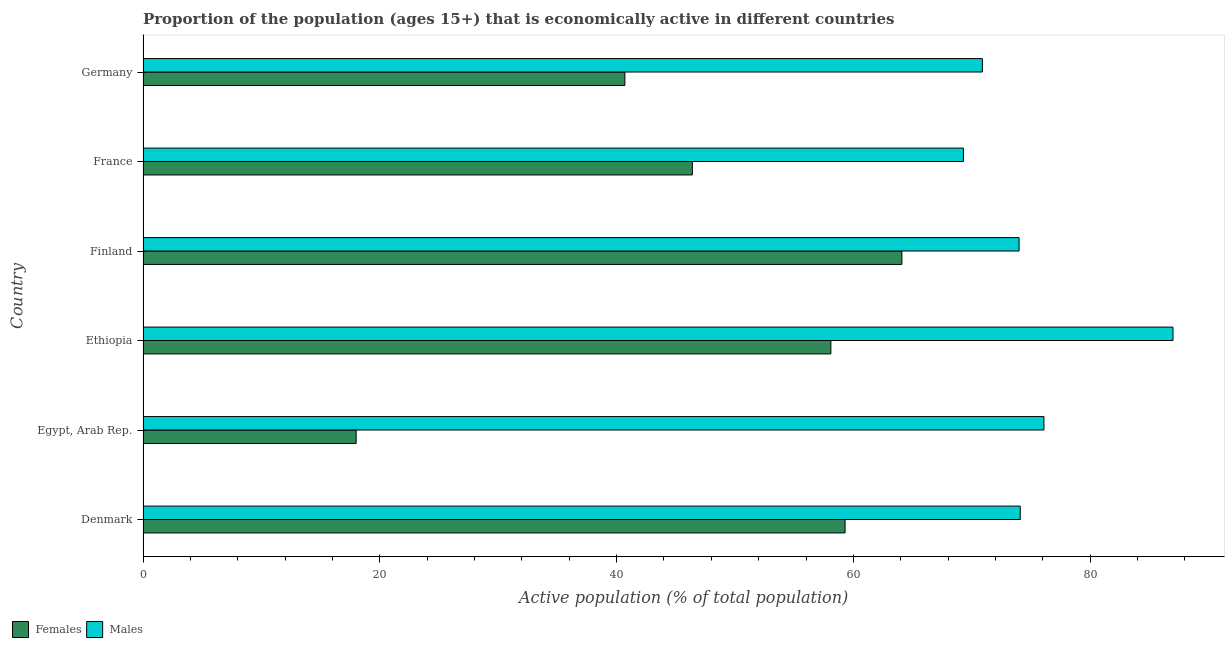How many different coloured bars are there?
Give a very brief answer. 2. Are the number of bars on each tick of the Y-axis equal?
Offer a terse response. Yes. How many bars are there on the 1st tick from the bottom?
Make the answer very short. 2. What is the label of the 2nd group of bars from the top?
Your response must be concise. France. In how many cases, is the number of bars for a given country not equal to the number of legend labels?
Your answer should be very brief. 0. What is the percentage of economically active male population in Germany?
Offer a very short reply. 70.9. Across all countries, what is the maximum percentage of economically active female population?
Keep it short and to the point. 64.1. Across all countries, what is the minimum percentage of economically active male population?
Your answer should be very brief. 69.3. In which country was the percentage of economically active female population maximum?
Provide a short and direct response. Finland. In which country was the percentage of economically active female population minimum?
Provide a succinct answer. Egypt, Arab Rep. What is the total percentage of economically active female population in the graph?
Your response must be concise. 286.6. What is the difference between the percentage of economically active male population in Finland and that in France?
Your answer should be compact. 4.7. What is the difference between the percentage of economically active male population in Finland and the percentage of economically active female population in France?
Ensure brevity in your answer.  27.6. What is the average percentage of economically active female population per country?
Your response must be concise. 47.77. What is the difference between the percentage of economically active male population and percentage of economically active female population in Denmark?
Your response must be concise. 14.8. What is the ratio of the percentage of economically active male population in Egypt, Arab Rep. to that in Germany?
Offer a terse response. 1.07. Is the percentage of economically active male population in Egypt, Arab Rep. less than that in Finland?
Provide a short and direct response. No. What is the difference between the highest and the lowest percentage of economically active female population?
Your response must be concise. 46.1. In how many countries, is the percentage of economically active male population greater than the average percentage of economically active male population taken over all countries?
Provide a succinct answer. 2. Is the sum of the percentage of economically active female population in Ethiopia and Finland greater than the maximum percentage of economically active male population across all countries?
Your answer should be compact. Yes. What does the 1st bar from the top in Ethiopia represents?
Provide a succinct answer. Males. What does the 2nd bar from the bottom in France represents?
Your answer should be compact. Males. What is the title of the graph?
Provide a short and direct response. Proportion of the population (ages 15+) that is economically active in different countries. Does "Infant" appear as one of the legend labels in the graph?
Provide a short and direct response. No. What is the label or title of the X-axis?
Provide a succinct answer. Active population (% of total population). What is the label or title of the Y-axis?
Provide a succinct answer. Country. What is the Active population (% of total population) in Females in Denmark?
Offer a terse response. 59.3. What is the Active population (% of total population) in Males in Denmark?
Ensure brevity in your answer.  74.1. What is the Active population (% of total population) of Males in Egypt, Arab Rep.?
Give a very brief answer. 76.1. What is the Active population (% of total population) in Females in Ethiopia?
Provide a succinct answer. 58.1. What is the Active population (% of total population) in Females in Finland?
Make the answer very short. 64.1. What is the Active population (% of total population) in Males in Finland?
Provide a short and direct response. 74. What is the Active population (% of total population) in Females in France?
Your answer should be compact. 46.4. What is the Active population (% of total population) of Males in France?
Ensure brevity in your answer.  69.3. What is the Active population (% of total population) in Females in Germany?
Make the answer very short. 40.7. What is the Active population (% of total population) of Males in Germany?
Your response must be concise. 70.9. Across all countries, what is the maximum Active population (% of total population) in Females?
Offer a terse response. 64.1. Across all countries, what is the minimum Active population (% of total population) in Females?
Offer a terse response. 18. Across all countries, what is the minimum Active population (% of total population) in Males?
Your response must be concise. 69.3. What is the total Active population (% of total population) of Females in the graph?
Your answer should be compact. 286.6. What is the total Active population (% of total population) of Males in the graph?
Your response must be concise. 451.4. What is the difference between the Active population (% of total population) of Females in Denmark and that in Egypt, Arab Rep.?
Offer a terse response. 41.3. What is the difference between the Active population (% of total population) of Males in Denmark and that in Egypt, Arab Rep.?
Give a very brief answer. -2. What is the difference between the Active population (% of total population) of Females in Denmark and that in Ethiopia?
Your answer should be compact. 1.2. What is the difference between the Active population (% of total population) of Males in Denmark and that in Ethiopia?
Ensure brevity in your answer.  -12.9. What is the difference between the Active population (% of total population) in Males in Denmark and that in Finland?
Provide a succinct answer. 0.1. What is the difference between the Active population (% of total population) in Females in Denmark and that in Germany?
Provide a short and direct response. 18.6. What is the difference between the Active population (% of total population) in Males in Denmark and that in Germany?
Ensure brevity in your answer.  3.2. What is the difference between the Active population (% of total population) in Females in Egypt, Arab Rep. and that in Ethiopia?
Your answer should be very brief. -40.1. What is the difference between the Active population (% of total population) in Females in Egypt, Arab Rep. and that in Finland?
Your answer should be very brief. -46.1. What is the difference between the Active population (% of total population) of Females in Egypt, Arab Rep. and that in France?
Offer a very short reply. -28.4. What is the difference between the Active population (% of total population) of Females in Egypt, Arab Rep. and that in Germany?
Provide a short and direct response. -22.7. What is the difference between the Active population (% of total population) of Males in Ethiopia and that in Finland?
Your answer should be compact. 13. What is the difference between the Active population (% of total population) of Males in Ethiopia and that in France?
Provide a short and direct response. 17.7. What is the difference between the Active population (% of total population) in Males in Ethiopia and that in Germany?
Ensure brevity in your answer.  16.1. What is the difference between the Active population (% of total population) in Males in Finland and that in France?
Provide a succinct answer. 4.7. What is the difference between the Active population (% of total population) of Females in Finland and that in Germany?
Offer a terse response. 23.4. What is the difference between the Active population (% of total population) of Females in France and that in Germany?
Offer a very short reply. 5.7. What is the difference between the Active population (% of total population) in Males in France and that in Germany?
Provide a short and direct response. -1.6. What is the difference between the Active population (% of total population) in Females in Denmark and the Active population (% of total population) in Males in Egypt, Arab Rep.?
Keep it short and to the point. -16.8. What is the difference between the Active population (% of total population) of Females in Denmark and the Active population (% of total population) of Males in Ethiopia?
Your answer should be very brief. -27.7. What is the difference between the Active population (% of total population) in Females in Denmark and the Active population (% of total population) in Males in Finland?
Ensure brevity in your answer.  -14.7. What is the difference between the Active population (% of total population) in Females in Denmark and the Active population (% of total population) in Males in France?
Your response must be concise. -10. What is the difference between the Active population (% of total population) of Females in Denmark and the Active population (% of total population) of Males in Germany?
Your answer should be compact. -11.6. What is the difference between the Active population (% of total population) in Females in Egypt, Arab Rep. and the Active population (% of total population) in Males in Ethiopia?
Keep it short and to the point. -69. What is the difference between the Active population (% of total population) in Females in Egypt, Arab Rep. and the Active population (% of total population) in Males in Finland?
Provide a succinct answer. -56. What is the difference between the Active population (% of total population) in Females in Egypt, Arab Rep. and the Active population (% of total population) in Males in France?
Offer a very short reply. -51.3. What is the difference between the Active population (% of total population) of Females in Egypt, Arab Rep. and the Active population (% of total population) of Males in Germany?
Give a very brief answer. -52.9. What is the difference between the Active population (% of total population) in Females in Ethiopia and the Active population (% of total population) in Males in Finland?
Your answer should be compact. -15.9. What is the difference between the Active population (% of total population) of Females in Ethiopia and the Active population (% of total population) of Males in France?
Keep it short and to the point. -11.2. What is the difference between the Active population (% of total population) in Females in Finland and the Active population (% of total population) in Males in France?
Provide a succinct answer. -5.2. What is the difference between the Active population (% of total population) of Females in Finland and the Active population (% of total population) of Males in Germany?
Ensure brevity in your answer.  -6.8. What is the difference between the Active population (% of total population) in Females in France and the Active population (% of total population) in Males in Germany?
Make the answer very short. -24.5. What is the average Active population (% of total population) in Females per country?
Keep it short and to the point. 47.77. What is the average Active population (% of total population) in Males per country?
Offer a very short reply. 75.23. What is the difference between the Active population (% of total population) in Females and Active population (% of total population) in Males in Denmark?
Provide a succinct answer. -14.8. What is the difference between the Active population (% of total population) of Females and Active population (% of total population) of Males in Egypt, Arab Rep.?
Keep it short and to the point. -58.1. What is the difference between the Active population (% of total population) in Females and Active population (% of total population) in Males in Ethiopia?
Keep it short and to the point. -28.9. What is the difference between the Active population (% of total population) in Females and Active population (% of total population) in Males in France?
Provide a short and direct response. -22.9. What is the difference between the Active population (% of total population) of Females and Active population (% of total population) of Males in Germany?
Provide a short and direct response. -30.2. What is the ratio of the Active population (% of total population) in Females in Denmark to that in Egypt, Arab Rep.?
Give a very brief answer. 3.29. What is the ratio of the Active population (% of total population) of Males in Denmark to that in Egypt, Arab Rep.?
Offer a very short reply. 0.97. What is the ratio of the Active population (% of total population) of Females in Denmark to that in Ethiopia?
Your answer should be compact. 1.02. What is the ratio of the Active population (% of total population) in Males in Denmark to that in Ethiopia?
Ensure brevity in your answer.  0.85. What is the ratio of the Active population (% of total population) in Females in Denmark to that in Finland?
Ensure brevity in your answer.  0.93. What is the ratio of the Active population (% of total population) of Males in Denmark to that in Finland?
Offer a terse response. 1. What is the ratio of the Active population (% of total population) in Females in Denmark to that in France?
Offer a terse response. 1.28. What is the ratio of the Active population (% of total population) of Males in Denmark to that in France?
Offer a terse response. 1.07. What is the ratio of the Active population (% of total population) of Females in Denmark to that in Germany?
Provide a succinct answer. 1.46. What is the ratio of the Active population (% of total population) in Males in Denmark to that in Germany?
Make the answer very short. 1.05. What is the ratio of the Active population (% of total population) in Females in Egypt, Arab Rep. to that in Ethiopia?
Offer a very short reply. 0.31. What is the ratio of the Active population (% of total population) of Males in Egypt, Arab Rep. to that in Ethiopia?
Offer a terse response. 0.87. What is the ratio of the Active population (% of total population) in Females in Egypt, Arab Rep. to that in Finland?
Give a very brief answer. 0.28. What is the ratio of the Active population (% of total population) in Males in Egypt, Arab Rep. to that in Finland?
Give a very brief answer. 1.03. What is the ratio of the Active population (% of total population) in Females in Egypt, Arab Rep. to that in France?
Your response must be concise. 0.39. What is the ratio of the Active population (% of total population) of Males in Egypt, Arab Rep. to that in France?
Your response must be concise. 1.1. What is the ratio of the Active population (% of total population) of Females in Egypt, Arab Rep. to that in Germany?
Keep it short and to the point. 0.44. What is the ratio of the Active population (% of total population) in Males in Egypt, Arab Rep. to that in Germany?
Offer a very short reply. 1.07. What is the ratio of the Active population (% of total population) of Females in Ethiopia to that in Finland?
Your answer should be compact. 0.91. What is the ratio of the Active population (% of total population) in Males in Ethiopia to that in Finland?
Your response must be concise. 1.18. What is the ratio of the Active population (% of total population) of Females in Ethiopia to that in France?
Offer a very short reply. 1.25. What is the ratio of the Active population (% of total population) in Males in Ethiopia to that in France?
Give a very brief answer. 1.26. What is the ratio of the Active population (% of total population) in Females in Ethiopia to that in Germany?
Your answer should be compact. 1.43. What is the ratio of the Active population (% of total population) of Males in Ethiopia to that in Germany?
Provide a succinct answer. 1.23. What is the ratio of the Active population (% of total population) in Females in Finland to that in France?
Give a very brief answer. 1.38. What is the ratio of the Active population (% of total population) of Males in Finland to that in France?
Give a very brief answer. 1.07. What is the ratio of the Active population (% of total population) in Females in Finland to that in Germany?
Give a very brief answer. 1.57. What is the ratio of the Active population (% of total population) of Males in Finland to that in Germany?
Make the answer very short. 1.04. What is the ratio of the Active population (% of total population) of Females in France to that in Germany?
Your answer should be very brief. 1.14. What is the ratio of the Active population (% of total population) of Males in France to that in Germany?
Provide a succinct answer. 0.98. What is the difference between the highest and the second highest Active population (% of total population) of Females?
Provide a short and direct response. 4.8. What is the difference between the highest and the second highest Active population (% of total population) in Males?
Offer a terse response. 10.9. What is the difference between the highest and the lowest Active population (% of total population) of Females?
Provide a succinct answer. 46.1. What is the difference between the highest and the lowest Active population (% of total population) of Males?
Offer a terse response. 17.7. 